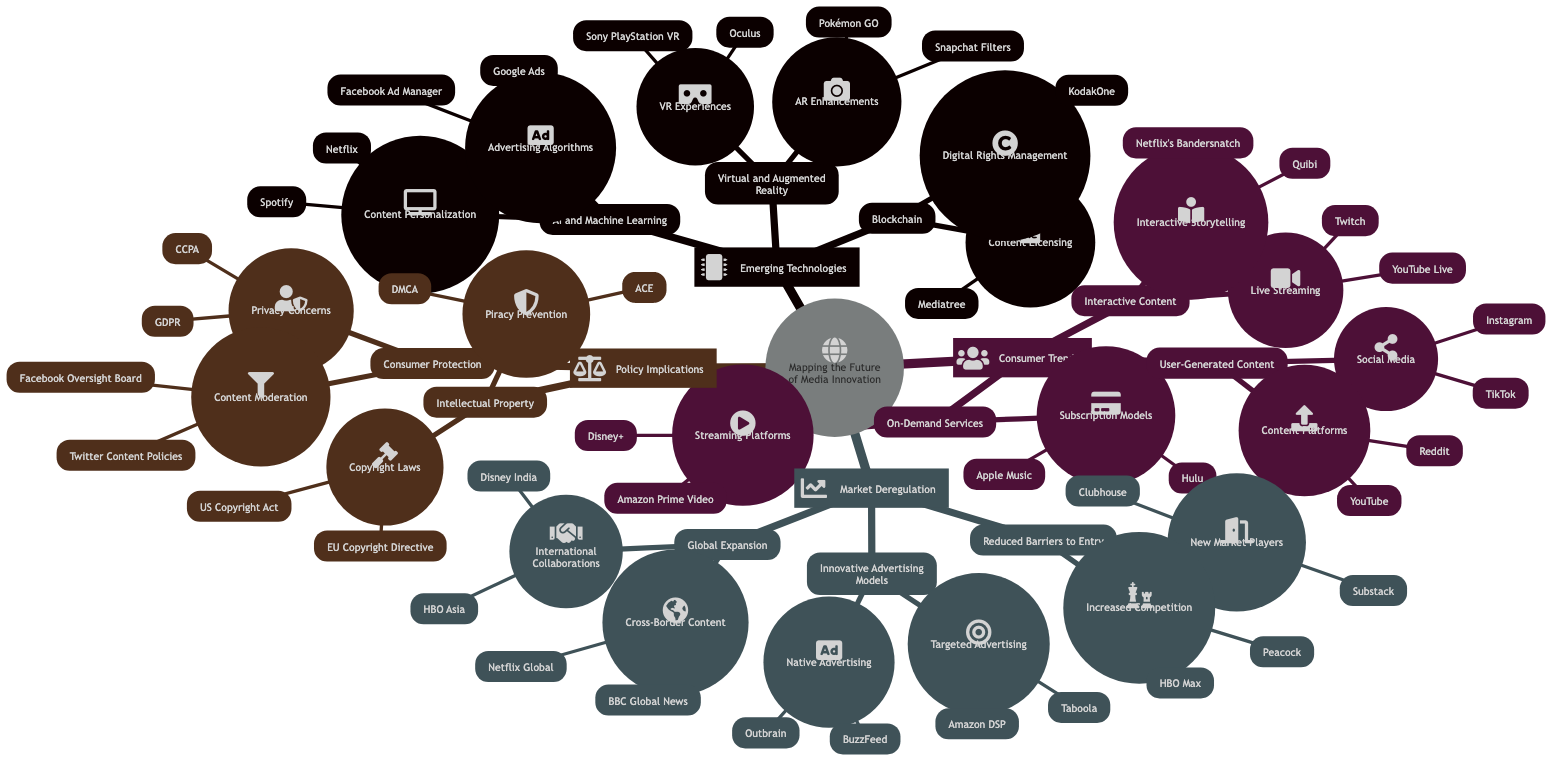What are two companies associated with content personalization under AI and Machine Learning? According to the diagram, two companies listed under Content Personalization in the AI and Machine Learning section are Netflix and Spotify.
Answer: Netflix, Spotify How many emerging technologies are listed in the diagram? The diagram lists three emerging technologies: AI and Machine Learning, Virtual and Augmented Reality, and Blockchain. Therefore, the count is three.
Answer: 3 Which platform falls under the Interactive Content section for live streaming? The diagram specifies Twitch and YouTube Live as platforms found under the Interactive Content section for Live Streaming.
Answer: Twitch, YouTube Live What are the two major concerns under Consumer Protection in the Policy Implications? The Policy Implications section highlights Privacy Concerns (GDPR, CCPA) and Content Moderation (Facebook Oversight Board, Twitter Content Policies) as the two major concerns under Consumer Protection.
Answer: Privacy Concerns, Content Moderation What is a new market player mentioned in the Market Deregulation segment? Clubhouse is identified as a new market player within the Reduced Barriers to Entry in the Market Deregulation section of the diagram.
Answer: Clubhouse Which two platforms are examples of User-Generated Content in Social Media? TikTok and Instagram are provided as examples of platforms associated with User-Generated Content within the Social Media subsection of the diagram.
Answer: TikTok, Instagram How many types of innovative advertising models are mentioned? The diagram includes two types of innovative advertising models: Targeted Advertising and Native Advertising. Therefore, the total count is two.
Answer: 2 Which two technologies are linked to Blockchain in the context of content management? The diagram indicates Content Licensing (Mediatree) and Digital Rights Management (KodakOne) as technologies linked to Blockchain in the context of content management.
Answer: Content Licensing, Digital Rights Management What is the relationship between emerging technologies and consumer trends according to the diagram? The relationship indicated in the diagram shows that emerging technologies (like AI and Machine Learning, VR/AR, and Blockchain) influence Consumer Trends (such as On-Demand Services, Interactive Content, and User-Generated Content), suggesting a strong connection between technological advancements and changing consumer behavior.
Answer: Influence of emerging technologies on consumer trends 